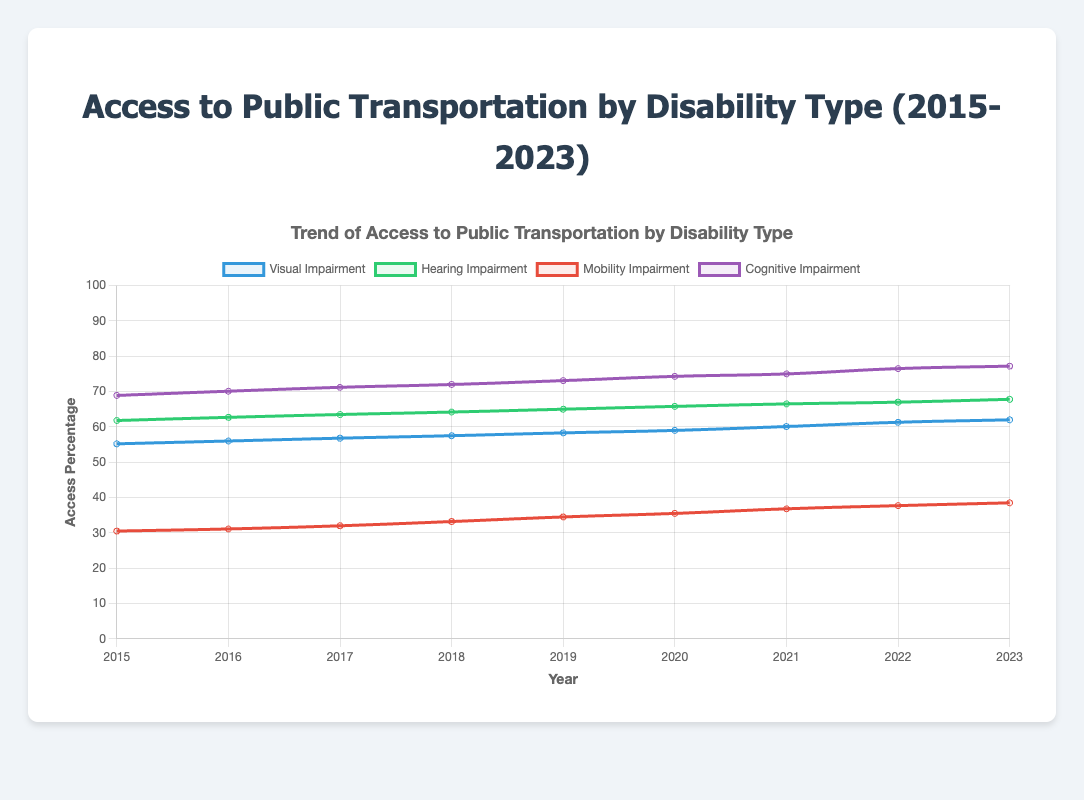What's the overall trend for access to public transportation for individuals with cognitive impairment from 2015 to 2023? The data shows an increasing trend. In 2015, the access percentage was 68.9%, and it increased steadily each year, reaching 77.2% in 2023.
Answer: Increasing trend Which disability type shows the highest access to public transportation in 2023? By looking at the 2023 data, the cognitive impairment group has the highest access percentage at 77.2%.
Answer: Cognitive impairment How much has access increased for those with visual impairment between 2015 and 2023? The access percentage for visual impairment increased from 55.2% in 2015 to 62.0% in 2023. Therefore, the increase is 62.0% - 55.2% = 6.8%.
Answer: 6.8% Compare the access to public transportation in 2019 for hearing impairment and mobility impairment. Which one had better access and by how much? In 2019, the access percentage for hearing impairment was 65.0%, while for mobility impairment it was 34.5%. So, hearing impairment had better access by 65.0% - 34.5% = 30.5%.
Answer: Hearing impairment by 30.5% Which year saw the largest increase in access for those with mobility impairments? By calculating the yearly increments, the largest increase was from 2018 to 2019, where it went up by 34.5% - 33.2% = 1.3%.
Answer: 2018 to 2019 What visual attribute represents the access levels for cognitive impairments in the chart? The cognitive impairment access levels are represented by a purple line which indicates its trend over the years.
Answer: Purple line Is the access trend for hearing impairments relatively smooth or fluctuating? The trend line for hearing impairments is relatively smooth with a steady year-over-year increase from 61.8% in 2015 to 67.8% in 2023.
Answer: Smooth and steady increase What is the overall difference in access percentage between visual and mobility impairments in 2023? In 2023, visual impairment access was 62.0% and mobility impairment was 38.5%. The difference is 62.0% - 38.5% = 23.5%.
Answer: 23.5% How has access for those with mobility impairment changed from 2015 to 2023 compared to hearing impairment? From 2015 to 2023, the mobility impairment access increased from 30.5% to 38.5% (an increase of 8.0%), while hearing impairment access increased from 61.8% to 67.8% (an increase of 6.0%).
Answer: Mobility impairment by 8%, Hearing impairment by 6% 